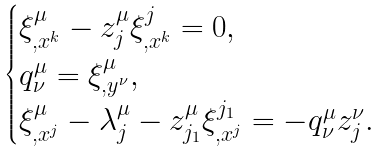Convert formula to latex. <formula><loc_0><loc_0><loc_500><loc_500>\begin{cases} \xi ^ { \mu } _ { , x ^ { k } } - z ^ { \mu } _ { j } \xi ^ { j } _ { , x ^ { k } } = 0 , \\ q ^ { \mu } _ { \nu } = \xi ^ { \mu } _ { , y ^ { \nu } } , \\ \xi ^ { \mu } _ { , x ^ { j } } - \lambda ^ { \mu } _ { j } - z ^ { \mu } _ { j _ { 1 } } \xi ^ { j _ { 1 } } _ { , x ^ { j } } = - q ^ { \mu } _ { \nu } z ^ { \nu } _ { j } . \end{cases}</formula> 